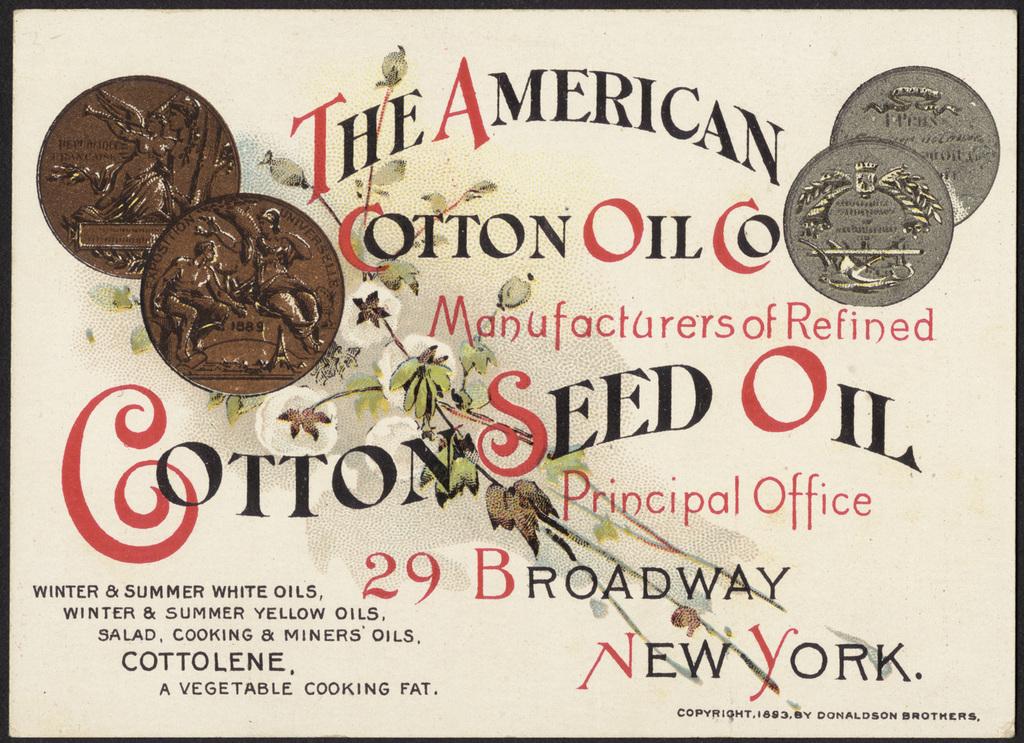What city is this cotton seed oil company from?
Ensure brevity in your answer.  New york. What kind of oil does cotton oil co manufacture?
Offer a very short reply. Cotton seed oil. 